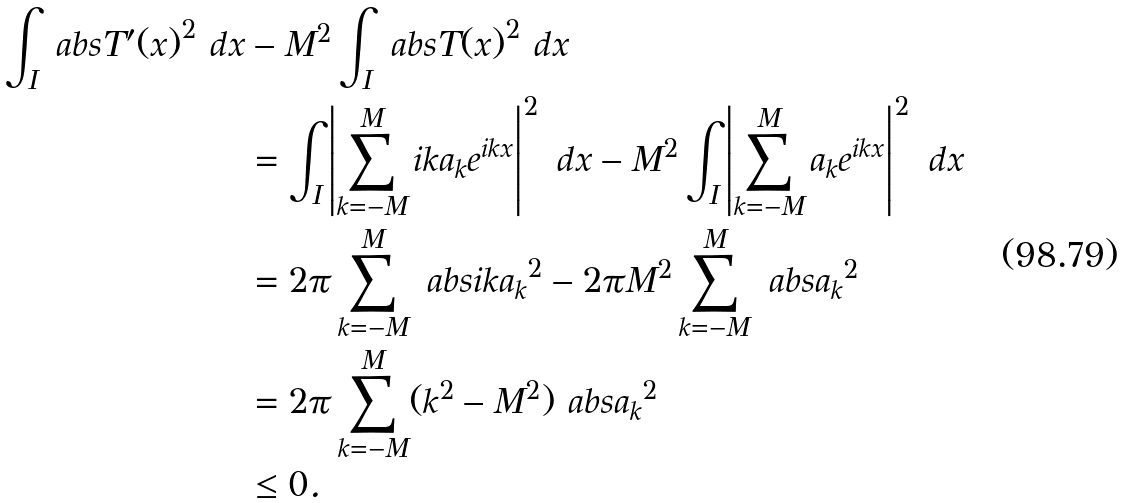Convert formula to latex. <formula><loc_0><loc_0><loc_500><loc_500>\int _ { I } \ a b s { T ^ { \prime } ( x ) } ^ { 2 } \ d x & - M ^ { 2 } \int _ { I } \ a b s { T ( x ) } ^ { 2 } \ d x \\ & = \int _ { I } \left | \sum _ { k = - M } ^ { M } i k a _ { k } e ^ { i k x } \right | ^ { 2 } \ d x - M ^ { 2 } \int _ { I } \left | \sum _ { k = - M } ^ { M } a _ { k } e ^ { i k x } \right | ^ { 2 } \ d x \\ & = 2 \pi \sum _ { k = - M } ^ { M } \ a b s { i k a _ { k } } ^ { 2 } - 2 \pi M ^ { 2 } \sum _ { k = - M } ^ { M } \ a b s { a _ { k } } ^ { 2 } \\ & = 2 \pi \sum _ { k = - M } ^ { M } ( k ^ { 2 } - M ^ { 2 } ) \ a b s { a _ { k } } ^ { 2 } \\ & \leq 0 .</formula> 